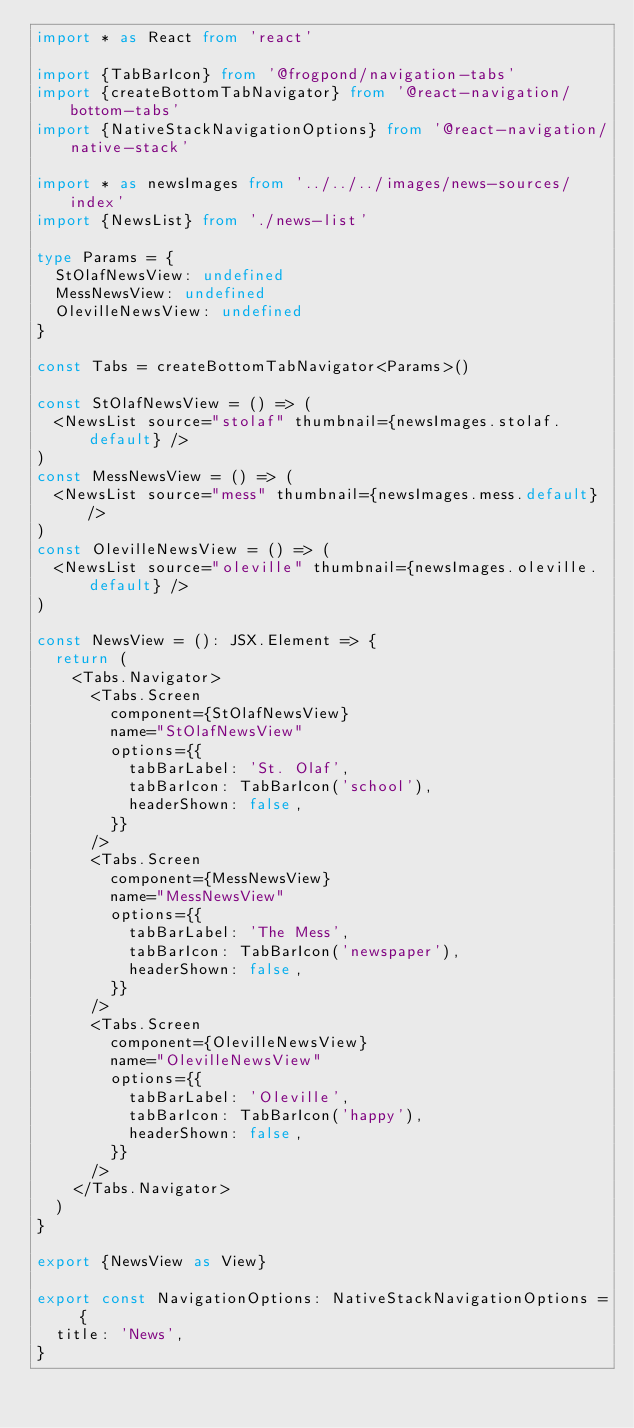<code> <loc_0><loc_0><loc_500><loc_500><_TypeScript_>import * as React from 'react'

import {TabBarIcon} from '@frogpond/navigation-tabs'
import {createBottomTabNavigator} from '@react-navigation/bottom-tabs'
import {NativeStackNavigationOptions} from '@react-navigation/native-stack'

import * as newsImages from '../../../images/news-sources/index'
import {NewsList} from './news-list'

type Params = {
	StOlafNewsView: undefined
	MessNewsView: undefined
	OlevilleNewsView: undefined
}

const Tabs = createBottomTabNavigator<Params>()

const StOlafNewsView = () => (
	<NewsList source="stolaf" thumbnail={newsImages.stolaf.default} />
)
const MessNewsView = () => (
	<NewsList source="mess" thumbnail={newsImages.mess.default} />
)
const OlevilleNewsView = () => (
	<NewsList source="oleville" thumbnail={newsImages.oleville.default} />
)

const NewsView = (): JSX.Element => {
	return (
		<Tabs.Navigator>
			<Tabs.Screen
				component={StOlafNewsView}
				name="StOlafNewsView"
				options={{
					tabBarLabel: 'St. Olaf',
					tabBarIcon: TabBarIcon('school'),
					headerShown: false,
				}}
			/>
			<Tabs.Screen
				component={MessNewsView}
				name="MessNewsView"
				options={{
					tabBarLabel: 'The Mess',
					tabBarIcon: TabBarIcon('newspaper'),
					headerShown: false,
				}}
			/>
			<Tabs.Screen
				component={OlevilleNewsView}
				name="OlevilleNewsView"
				options={{
					tabBarLabel: 'Oleville',
					tabBarIcon: TabBarIcon('happy'),
					headerShown: false,
				}}
			/>
		</Tabs.Navigator>
	)
}

export {NewsView as View}

export const NavigationOptions: NativeStackNavigationOptions = {
	title: 'News',
}
</code> 